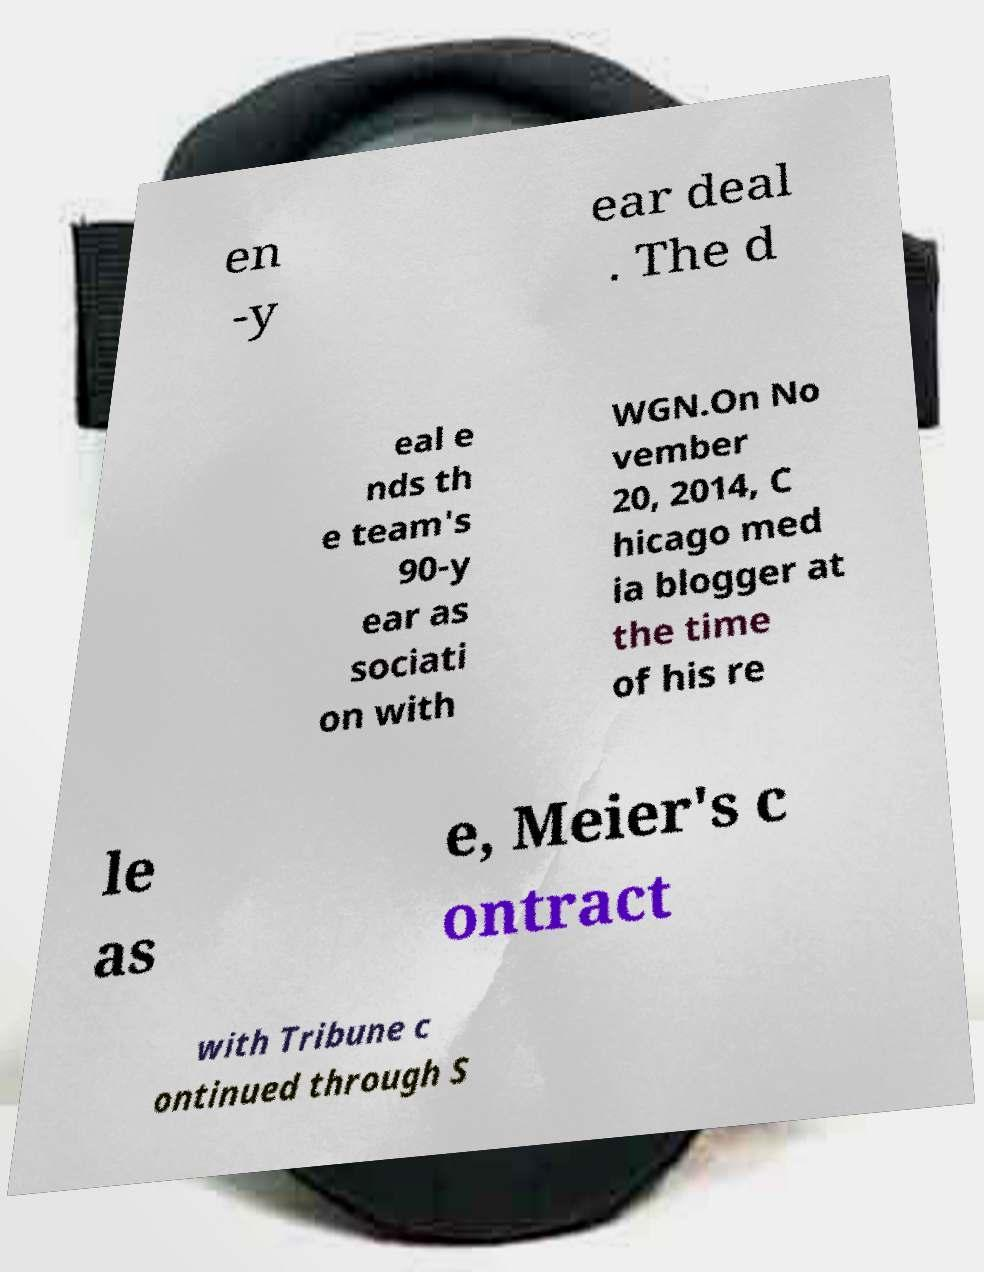What messages or text are displayed in this image? I need them in a readable, typed format. en -y ear deal . The d eal e nds th e team's 90-y ear as sociati on with WGN.On No vember 20, 2014, C hicago med ia blogger at the time of his re le as e, Meier's c ontract with Tribune c ontinued through S 